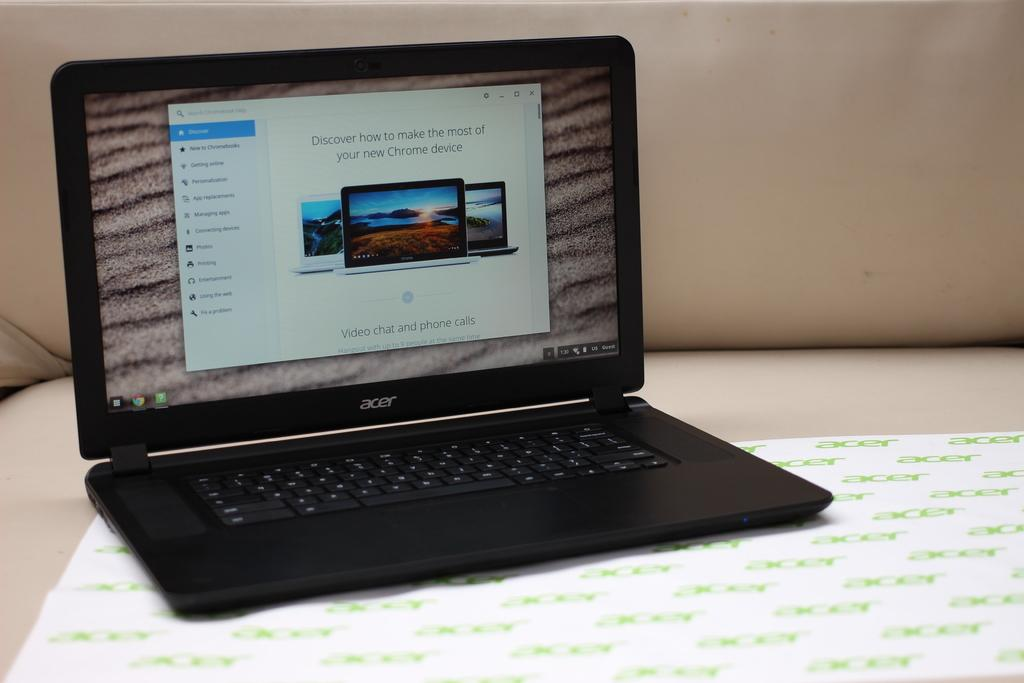<image>
Offer a succinct explanation of the picture presented. A black Acer model laptop with the monitor displaying a screen that says Video chat and phone calls 